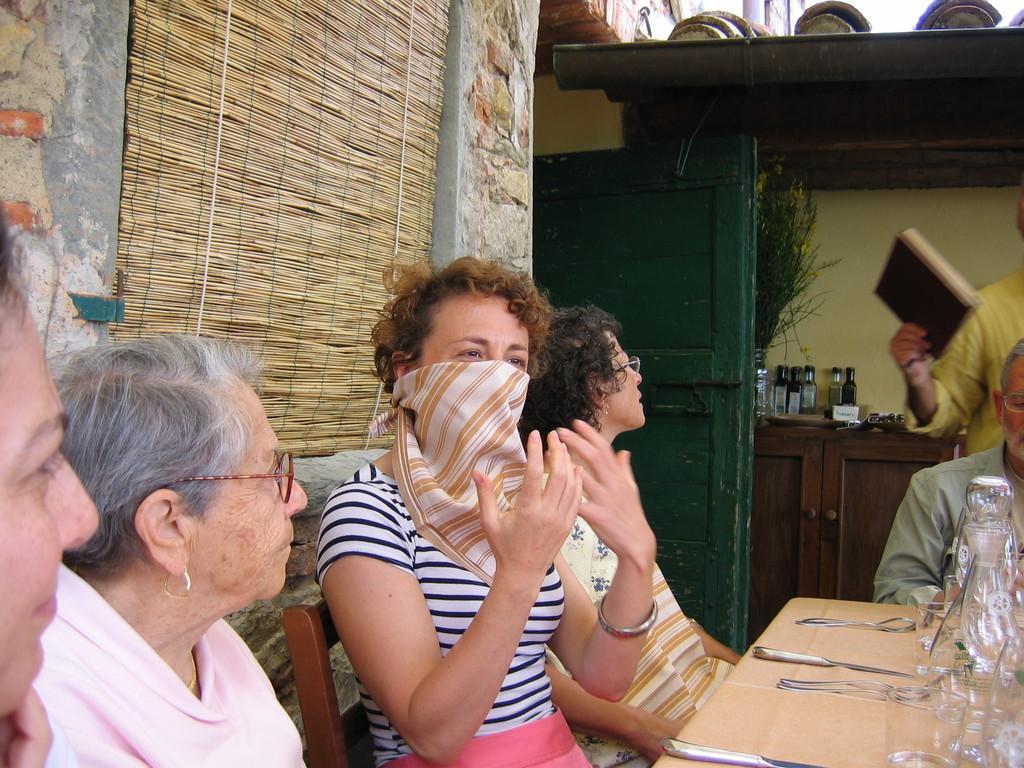In one or two sentences, can you explain what this image depicts? In this image there are group of sitting around the table. There is a person standing behind the table and holding a book. There are knives, bottles on the table. At the back there is a door, there are plants, bottles, cupboard behind the door and at the left there is a window. 